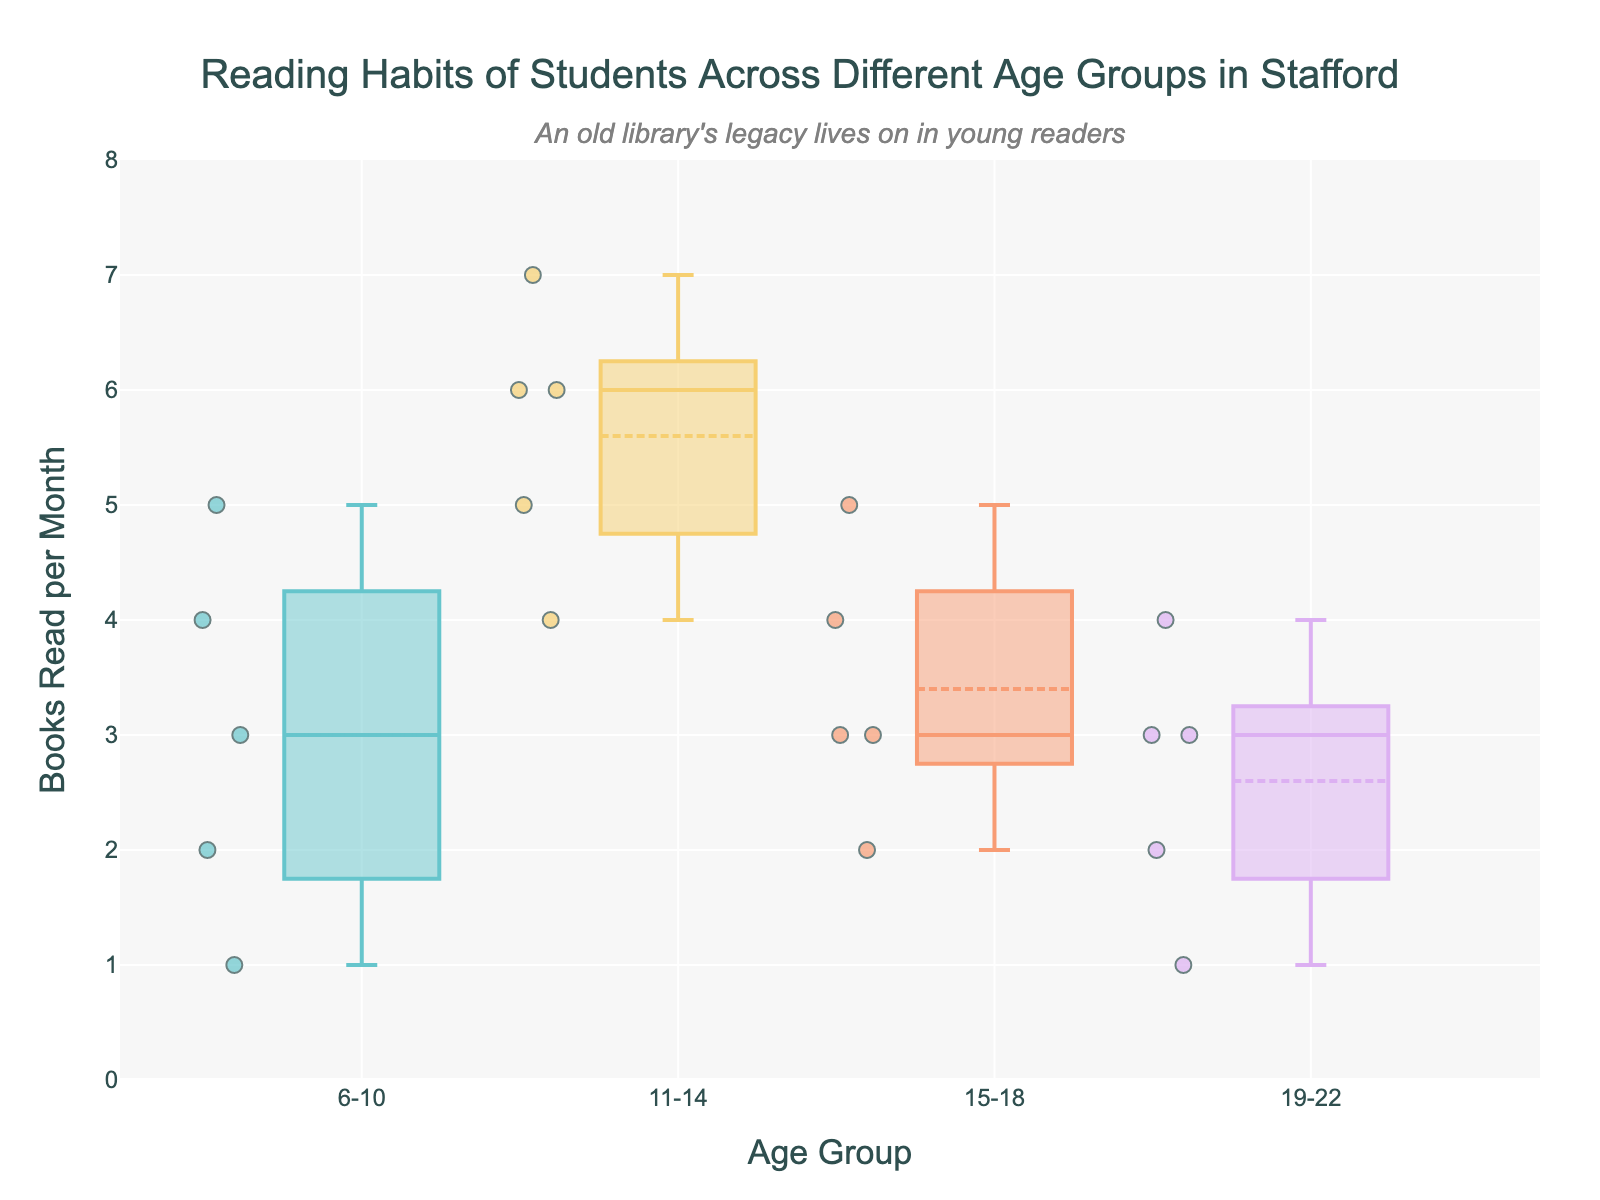What's the title of the figure? The title is the heading text at the top of the figure. It provides context and tells us what the figure is about.
Answer: Reading Habits of Students Across Different Age Groups in Stafford What are the age groups presented in the figure? The age groups are displayed on the x-axis of the box plot. These labels indicate the different categories of data presented.
Answer: 6-10, 11-14, 15-18, 19-22 Which age group has the highest median number of books read per month? The median is represented by the line in the middle of each box. By examining the box plot, we can identify which group's line is the highest.
Answer: 11-14 What is the interquartile range (IQR) for the age group 15-18? The IQR is the range between the first quartile (Q1) and the third quartile (Q3). It is represented by the length of the box. By looking at the box for the age group 15-18, we can measure this range.
Answer: 2 (from 2 to 4) Which age group has the most variation in the number of books read per month? The age group with the most variation will have the largest spread in the box plot, including the length of the whiskers and the distance between the maximum and minimum points.
Answer: 6-10 How do the reading habits of students between 6-10 compare to those of students between 19-22? By comparing the positions of the boxes and the scatter points for these two groups, we can assess the differences in reading habits, such as median, range, and outliers.
Answer: Students aged 6-10 read more books on average and have more variation compared to students aged 19-22 What can you infer about outliers in the age group 11-14? Outliers are represented as individual points outside the whiskers of the box plot. By observing the box for 11-14, we can note if any points lie outside the typical range.
Answer: No significant outliers What is the highest number of books read per month by any student, and which age group does this student belong to? The highest number of books read corresponds to the highest outlier or upper whisker limit in the box plot. We identify the peak point across all age groups.
Answer: 7, 11-14 Which age group has the smallest range of books read per month? The range is represented by the total length from the minimum to maximum points, including the whiskers. We look for the shortest spread in the box plot.
Answer: 19-22 Is there any age group where students read fewer than 2 books at the maximum? By examining the box plots and the maximum whisker length, we can identify if any group's maximum is fewer than 2 books.
Answer: None 